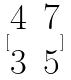<formula> <loc_0><loc_0><loc_500><loc_500>[ \begin{matrix} 4 & 7 \\ 3 & 5 \end{matrix} ]</formula> 